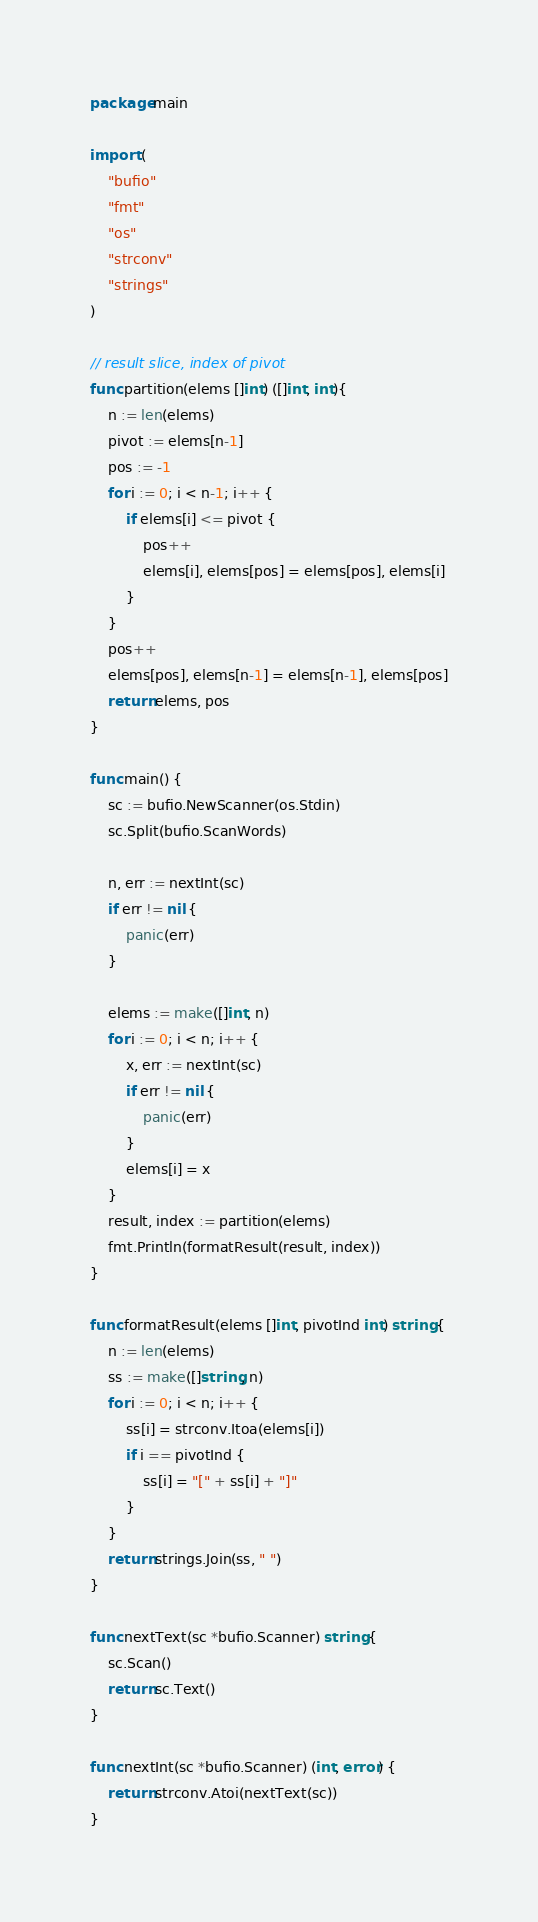<code> <loc_0><loc_0><loc_500><loc_500><_Go_>package main

import (
	"bufio"
	"fmt"
	"os"
	"strconv"
	"strings"
)

// result slice, index of pivot
func partition(elems []int) ([]int, int){
	n := len(elems)
	pivot := elems[n-1]
	pos := -1
	for i := 0; i < n-1; i++ {
		if elems[i] <= pivot {
			pos++
			elems[i], elems[pos] = elems[pos], elems[i]
		}
	}
	pos++
	elems[pos], elems[n-1] = elems[n-1], elems[pos]
	return elems, pos
}

func main() {
	sc := bufio.NewScanner(os.Stdin)
	sc.Split(bufio.ScanWords)

	n, err := nextInt(sc)
	if err != nil {
		panic(err)
	}

	elems := make([]int, n)
	for i := 0; i < n; i++ {
		x, err := nextInt(sc)
		if err != nil {
			panic(err)
		}
		elems[i] = x
	}
	result, index := partition(elems)
	fmt.Println(formatResult(result, index))
}

func formatResult(elems []int, pivotInd int) string {
	n := len(elems)
	ss := make([]string, n)
	for i := 0; i < n; i++ {
		ss[i] = strconv.Itoa(elems[i])
		if i == pivotInd {
			ss[i] = "[" + ss[i] + "]"
		}
	}
	return strings.Join(ss, " ")
}

func nextText(sc *bufio.Scanner) string {
	sc.Scan()
	return sc.Text()
}

func nextInt(sc *bufio.Scanner) (int, error) {
	return strconv.Atoi(nextText(sc))
}
</code> 